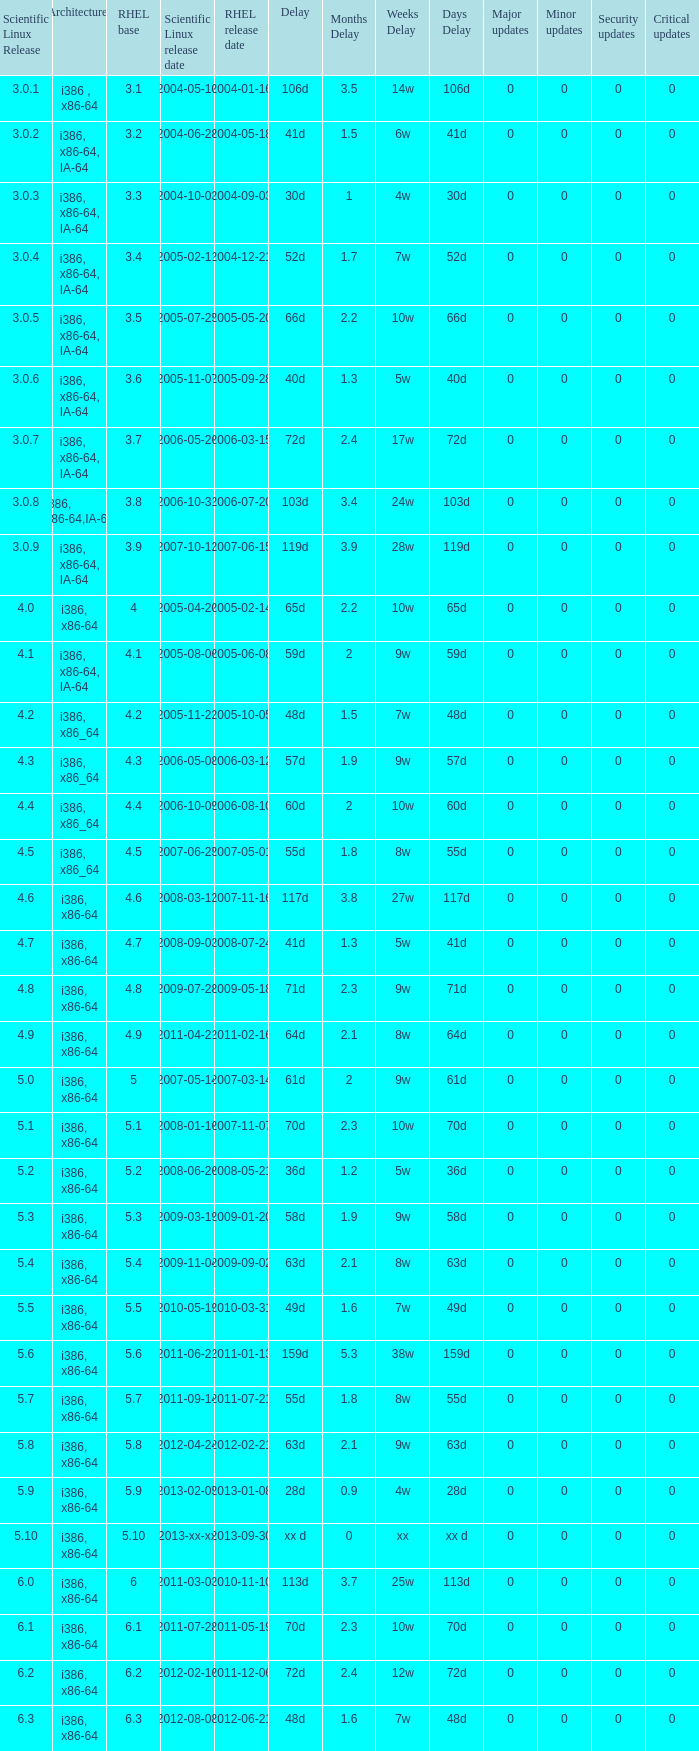When is the rhel release date when scientific linux release is 3.0.4 2004-12-21. 